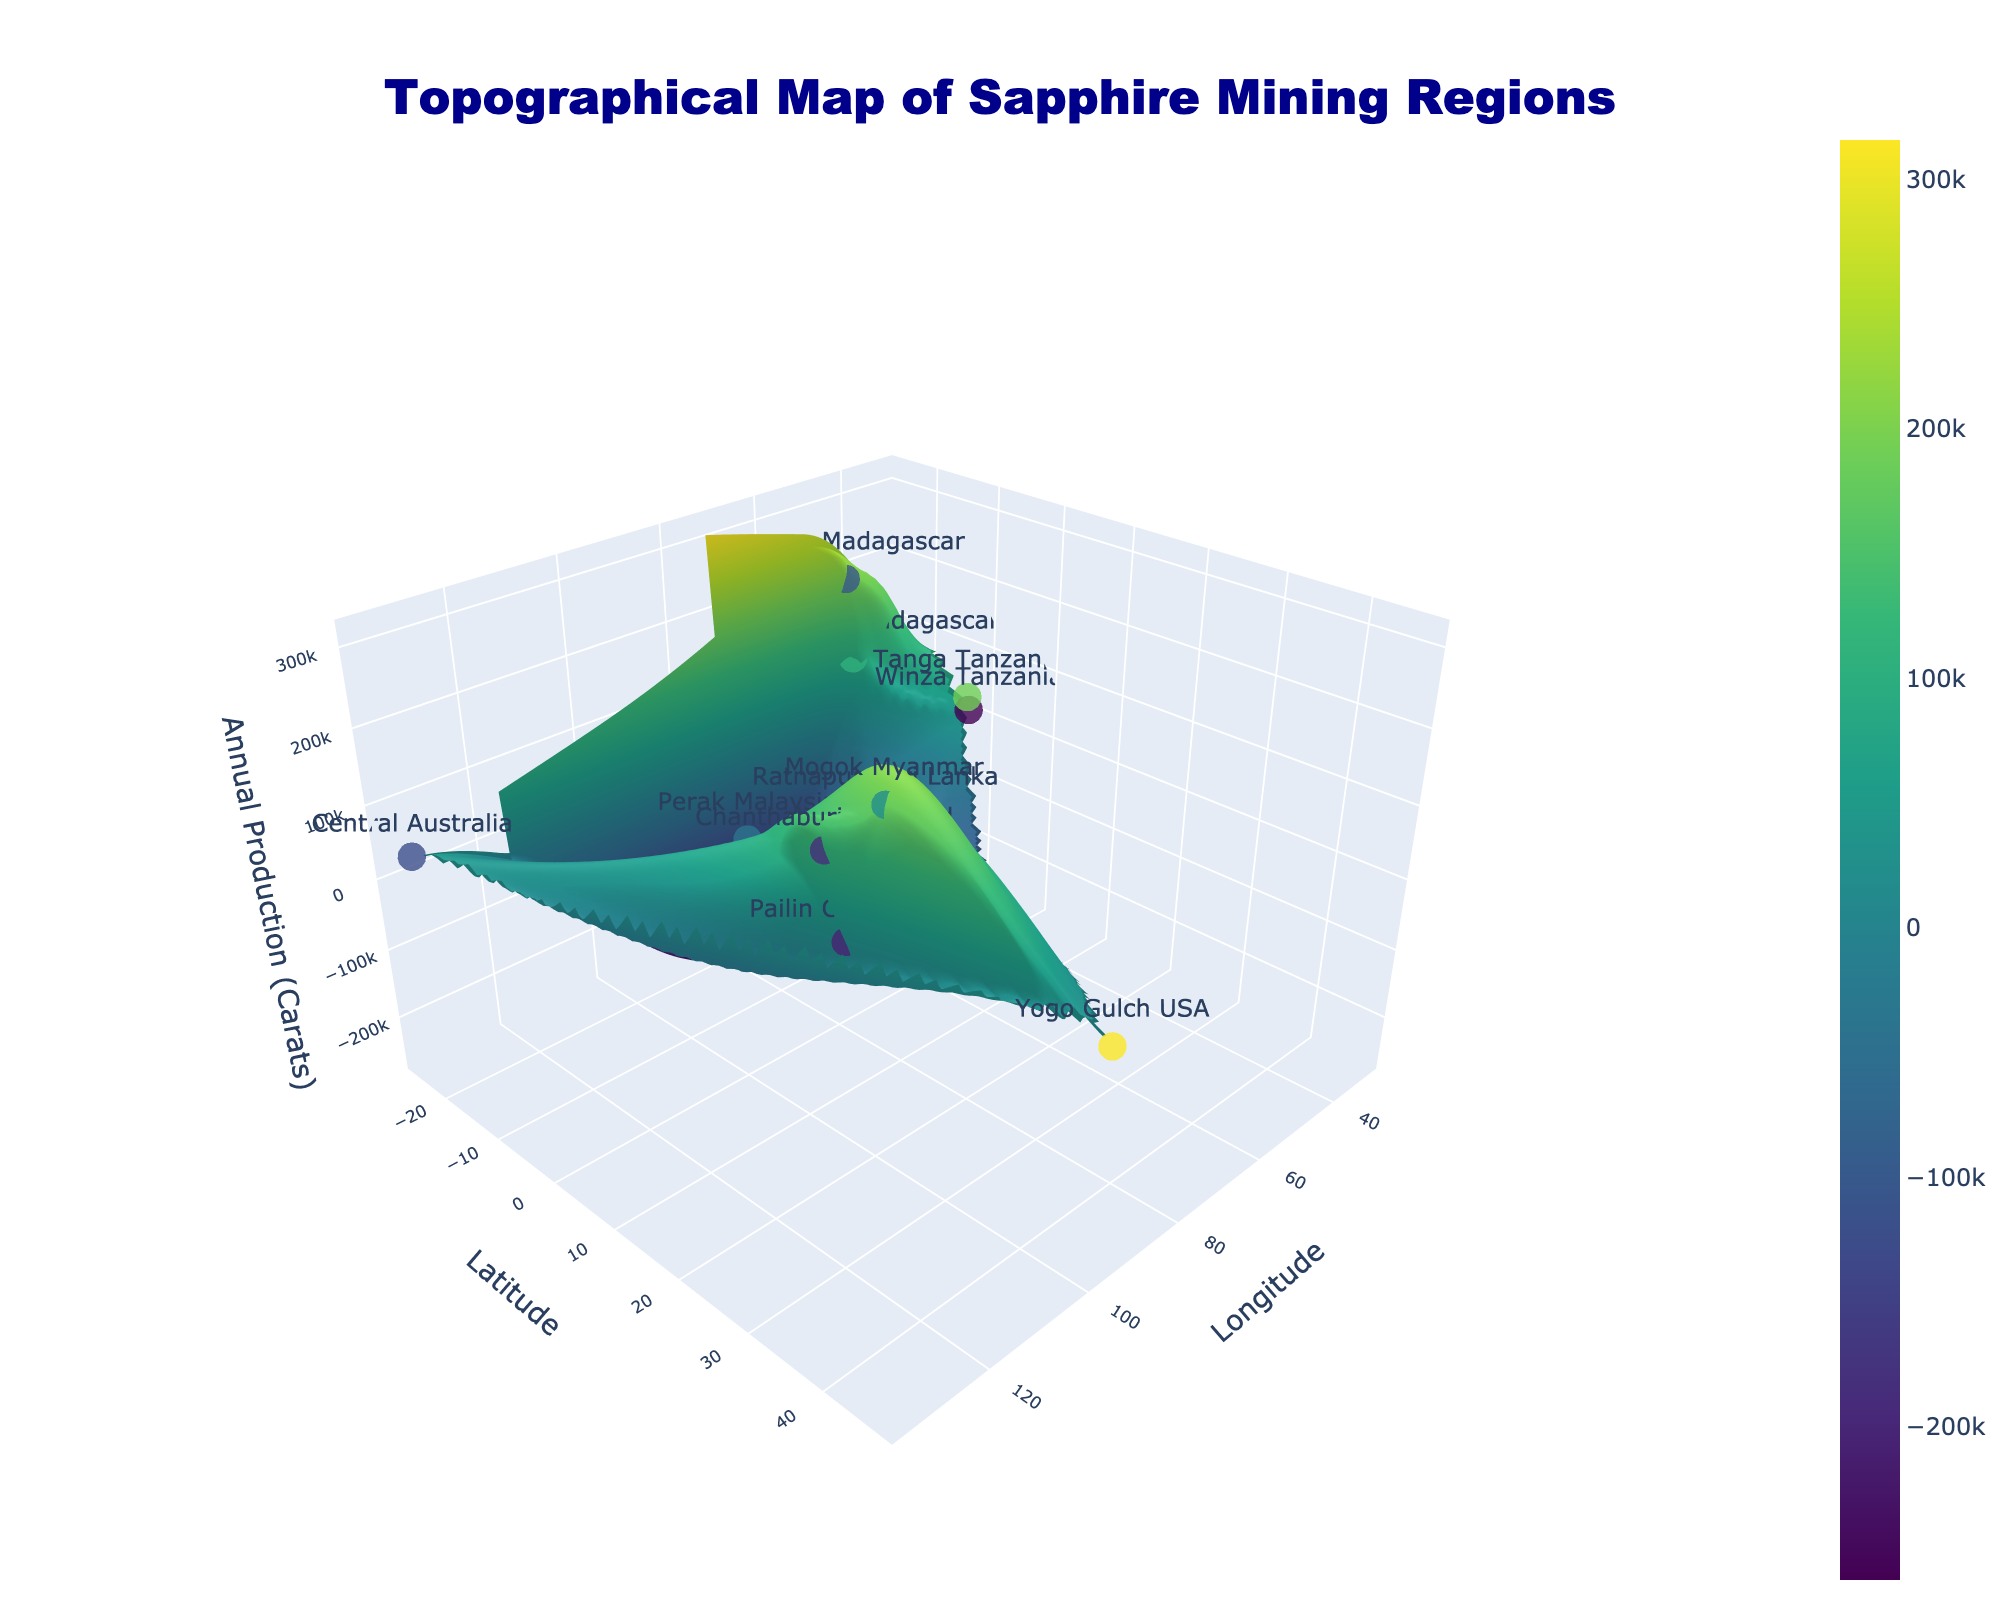What's the title of the figure? The title is located prominently at the top of the figure.
Answer: Topographical Map of Sapphire Mining Regions What does the Z-axis represent? The Z-axis title is labeled as "Annual Production (Carats)" in the figure, indicating it represents the annual production volume in carats.
Answer: Annual Production (Carats) Which region has the highest annual production of sapphires? By examining the peaks in the Z-axis and the related hover text on the markers, you can identify the highest annual production region.
Answer: Ilakaka Madagascar What is the latitude and longitude of the region with the lowest production volume? The lowest point on the Z-axis represents the lowest production volume, and the accompanying hover text displays its location.
Answer: 46.3, 94.3 Which region has a higher elevation: Winza Tanzania or Mogok Myanmar? Hovering over the markers reveals details about each region, including elevation.
Answer: Mogok Myanmar Compare the annual production volumes of Ratnapura Sri Lanka and Perak Malaysia. Which one produces more? Look at the height of the markers on the Z-axis and the hover text for accurate production volumes.
Answer: Perak Malaysia How does the elevation of Yogo Gulch USA compare to that of Tanga Tanzania? Hovering over each marker reveals the elevation and allows for a direct comparison.
Answer: Yogo Gulch USA is higher Calculate the average annual production of the regions in Tanzania. Sum the annual productions of Winza Tanzania (50000) and Tanga Tanzania (65000) then divide by 2. (50000 + 65000) / 2
Answer: 57500 Describe the color scale used in the figure. The color scale, Viridis, transitions from dark blue at lower values to bright yellow at higher values, correlating with the Z-axis values.
Answer: Dark blue to bright yellow Which two regions are closest to 101.5 in longitude? Look at the positions of the markers along the longitude axis close to 101.5 and match their hover text details.
Answer: Perak Malaysia and Chanthaburi Thailand 